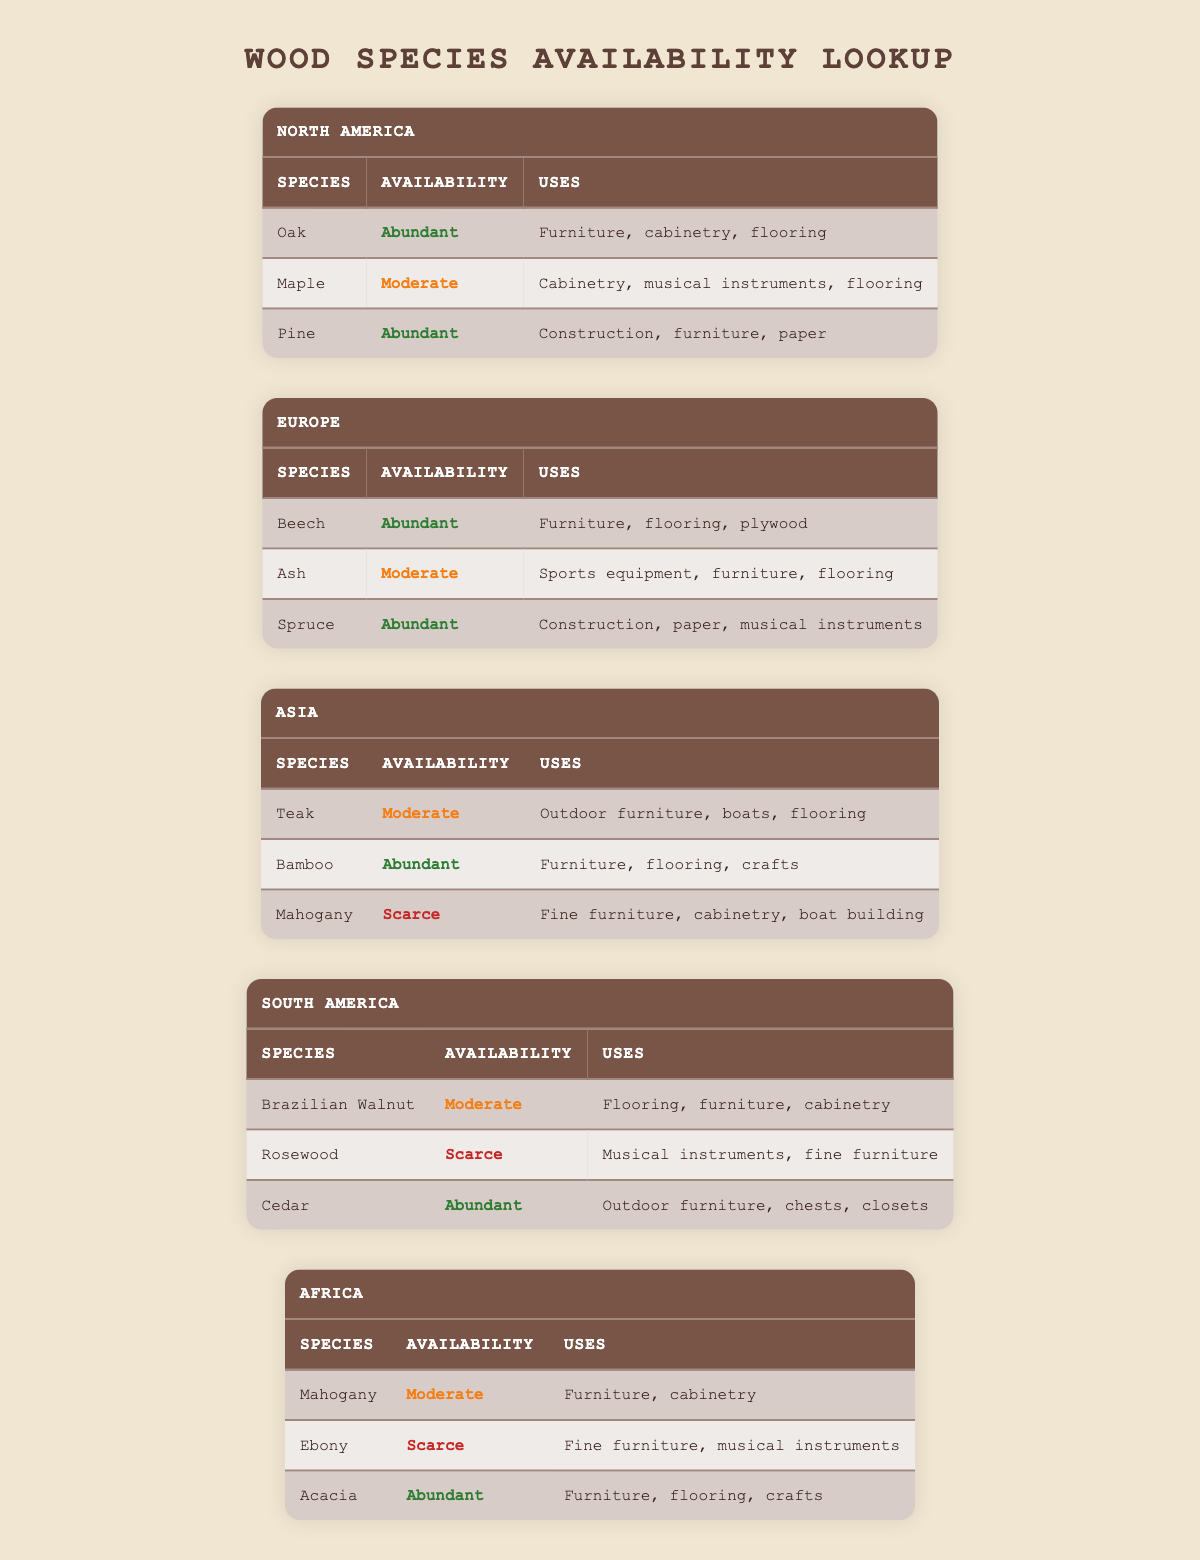What wood species are scarce in Asia? In the Asia section of the table, the species listed are Teak, Bamboo, and Mahogany. Upon checking their availability status, Mahogany is marked as scarce.
Answer: Mahogany How many wood species are available in South America? The South America section lists three species: Brazilian Walnut, Rosewood, and Cedar. Hence, there are three wood species available in this region.
Answer: Three Which wood species has moderate availability and is used for flooring in North America? In the North America section, Maple is listed with moderate availability and its uses include flooring.
Answer: Maple Is Cedar abundant in South America for outdoor furniture? The table shows that Cedar is abundant in South America, and one of its uses is specifically for outdoor furniture. Therefore, the statement is true.
Answer: Yes Which region has the largest number of abundant wood species? By examining the table, North America, Europe, South America, and Africa each have two or more wood species marked as abundant. However, Europe and South America both have three wood species available. Comparatively, Europe has Beech, Spruce, and two abundant species from South America (Cedar) along with two from Africa. Thus, Europe is confirmed for having multiple.
Answer: Europe and South America What is the average number of wood species mentioned across all regions? The total number of wood species from each region counts up to 15 (3 from North America, 3 from Europe, 3 from Asia, 3 from South America, and 3 from Africa). To find the average number across the 5 regions, we divide 15 by the 5 regions, resulting in an average of 3 species per region.
Answer: Three Are there any species that are both abundant and used for furniture in Africa? In the Africa section, Acacia is marked as abundant and is also listed for furniture use. This confirms that there is at least one species meeting both conditions.
Answer: Yes Which wood species is common for musical instruments in Europe and South America? Spruce in Europe and Rosewood in South America are identified for musical instruments. They vary between regions but do not share a common species for that use.
Answer: No What wood species in Asia is used for outdoor furniture? The Asia section mentions Teak, which has been explicitly listed for outdoor furniture use, indicating its relevance to the question.
Answer: Teak 